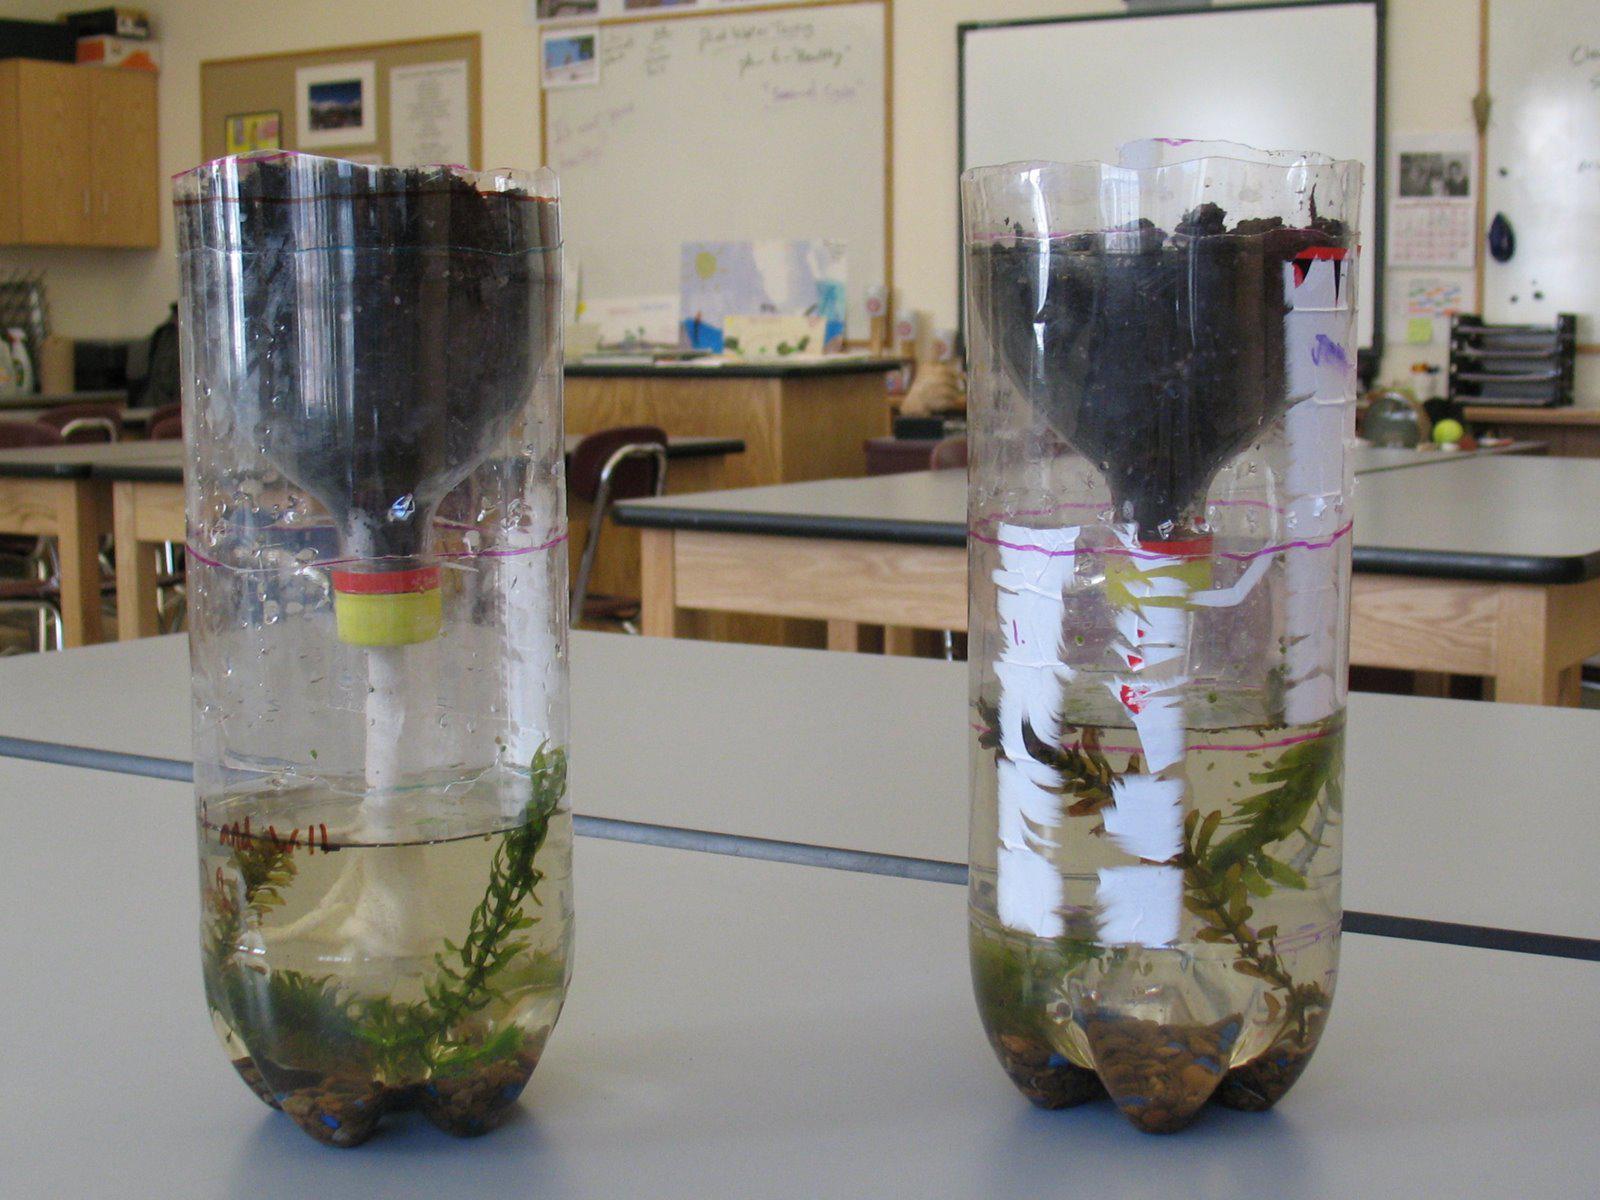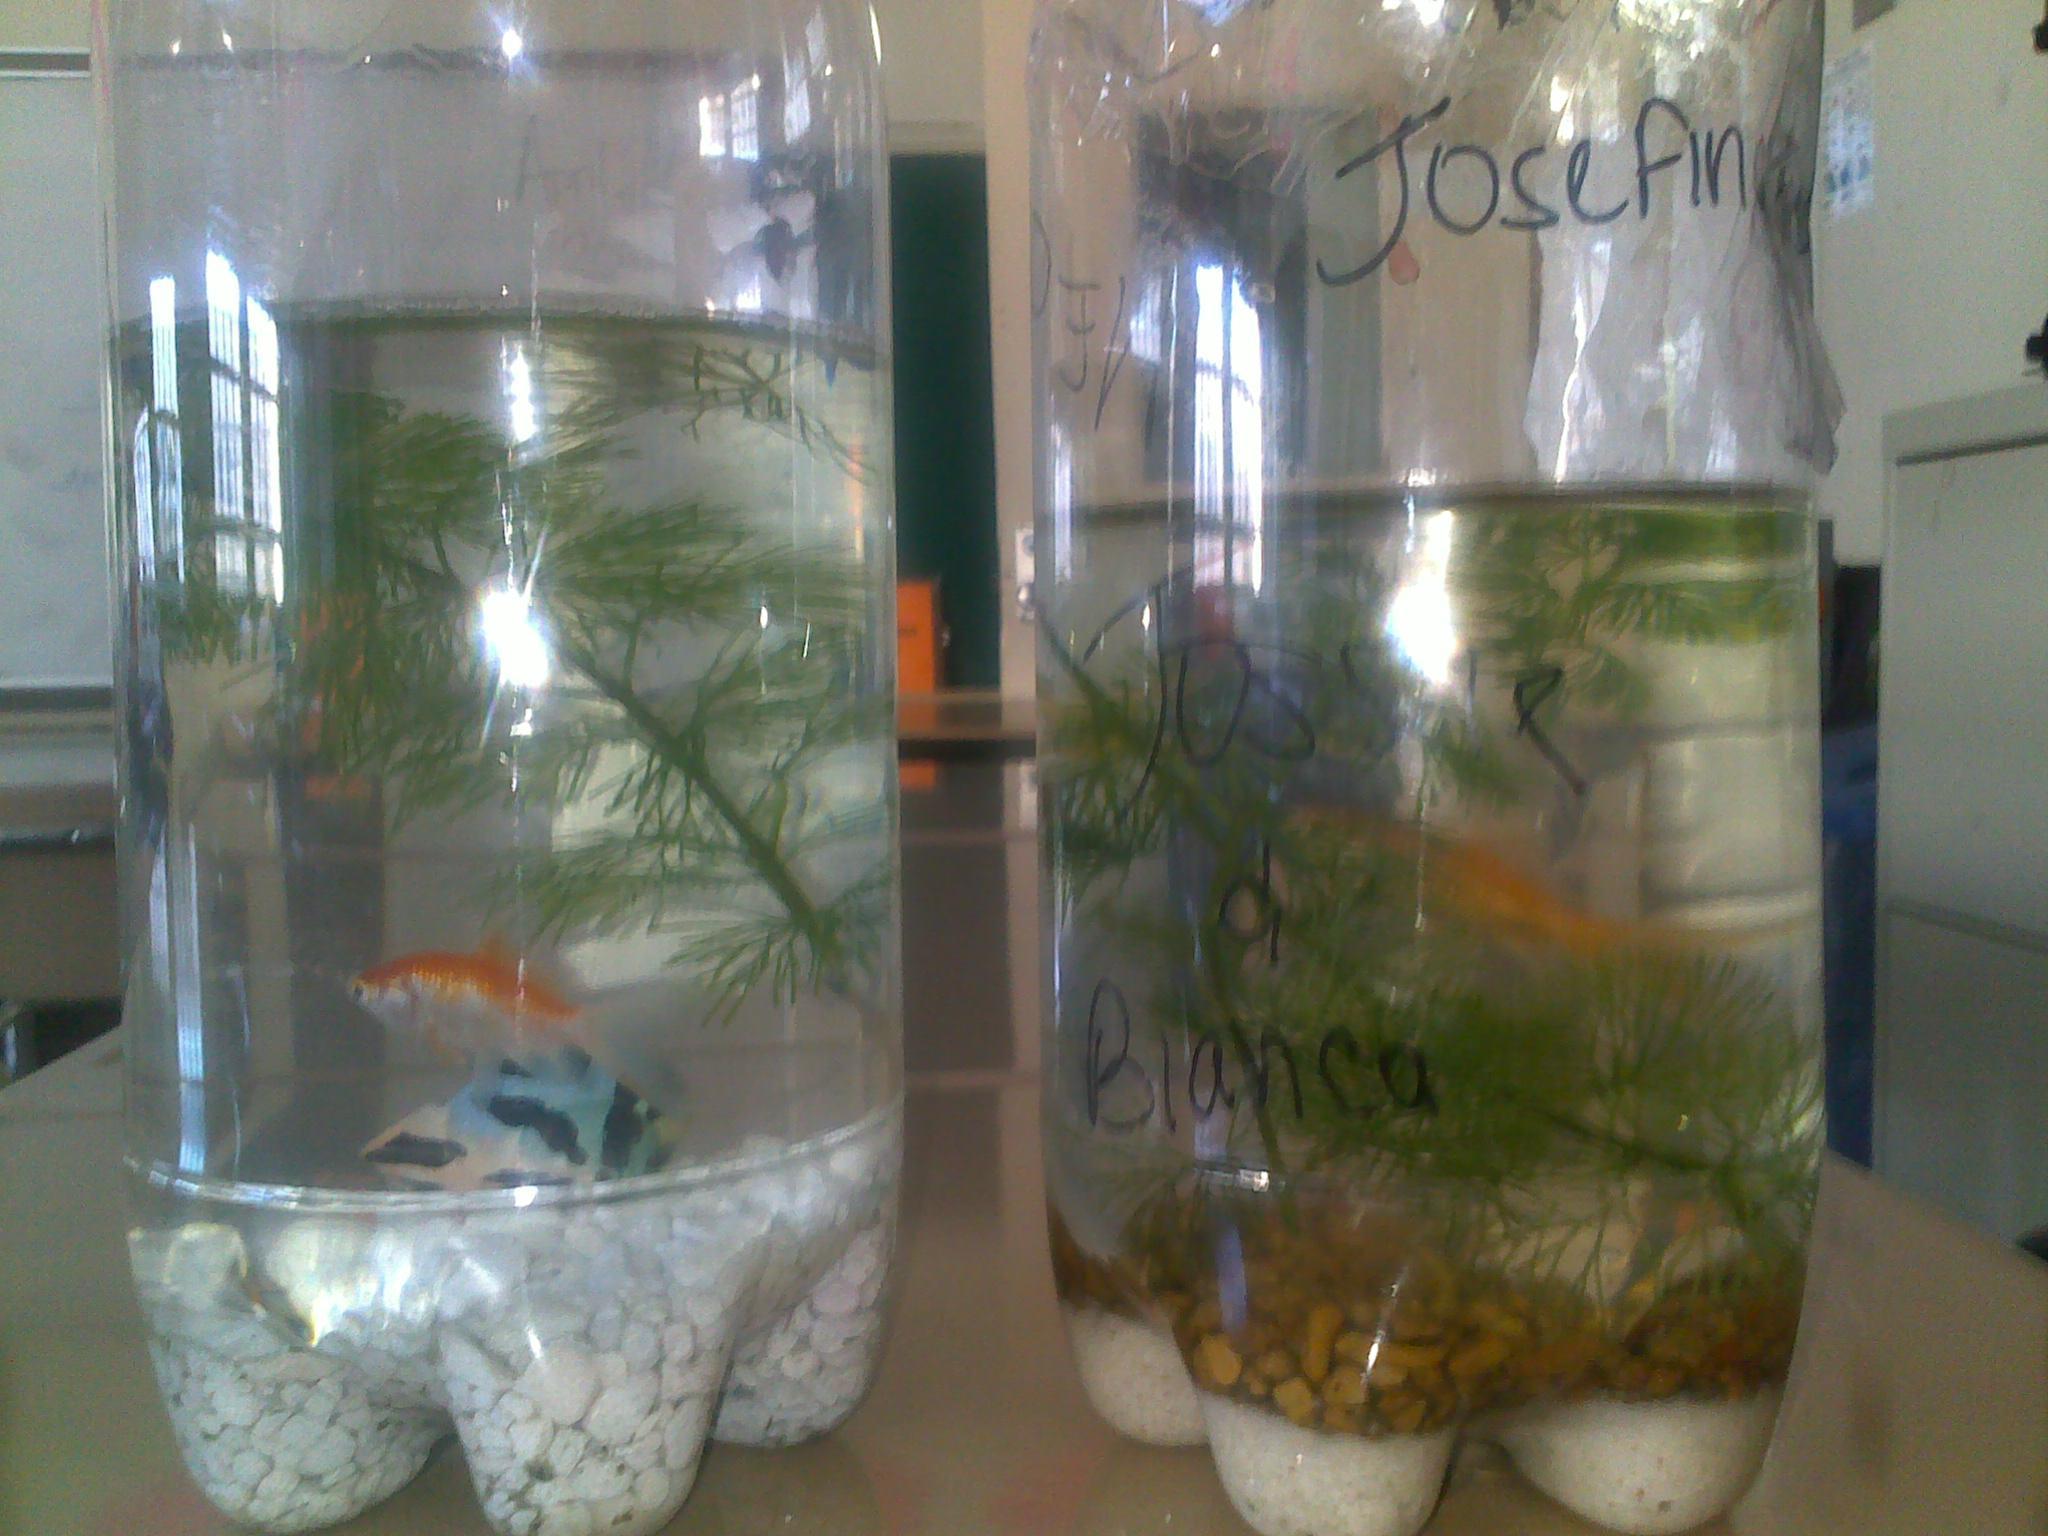The first image is the image on the left, the second image is the image on the right. Analyze the images presented: Is the assertion "There are more bottles in the image on the left." valid? Answer yes or no. No. The first image is the image on the left, the second image is the image on the right. Given the left and right images, does the statement "The combined images contain four bottle displays with green plants in them." hold true? Answer yes or no. Yes. 